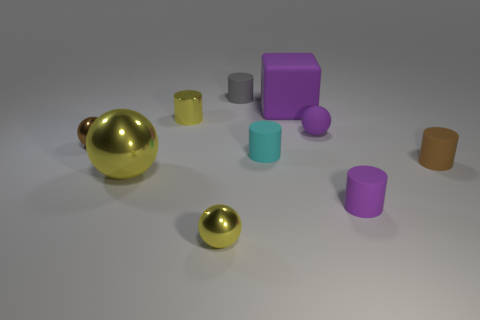Subtract all tiny matte cylinders. How many cylinders are left? 1 Subtract all purple cubes. How many yellow spheres are left? 2 Subtract all cyan cylinders. How many cylinders are left? 4 Subtract all yellow cylinders. Subtract all cyan spheres. How many cylinders are left? 4 Subtract all spheres. How many objects are left? 6 Subtract 2 spheres. How many spheres are left? 2 Subtract all small cylinders. Subtract all big blue matte cylinders. How many objects are left? 5 Add 2 tiny purple matte cylinders. How many tiny purple matte cylinders are left? 3 Add 3 small shiny spheres. How many small shiny spheres exist? 5 Subtract 1 purple cylinders. How many objects are left? 9 